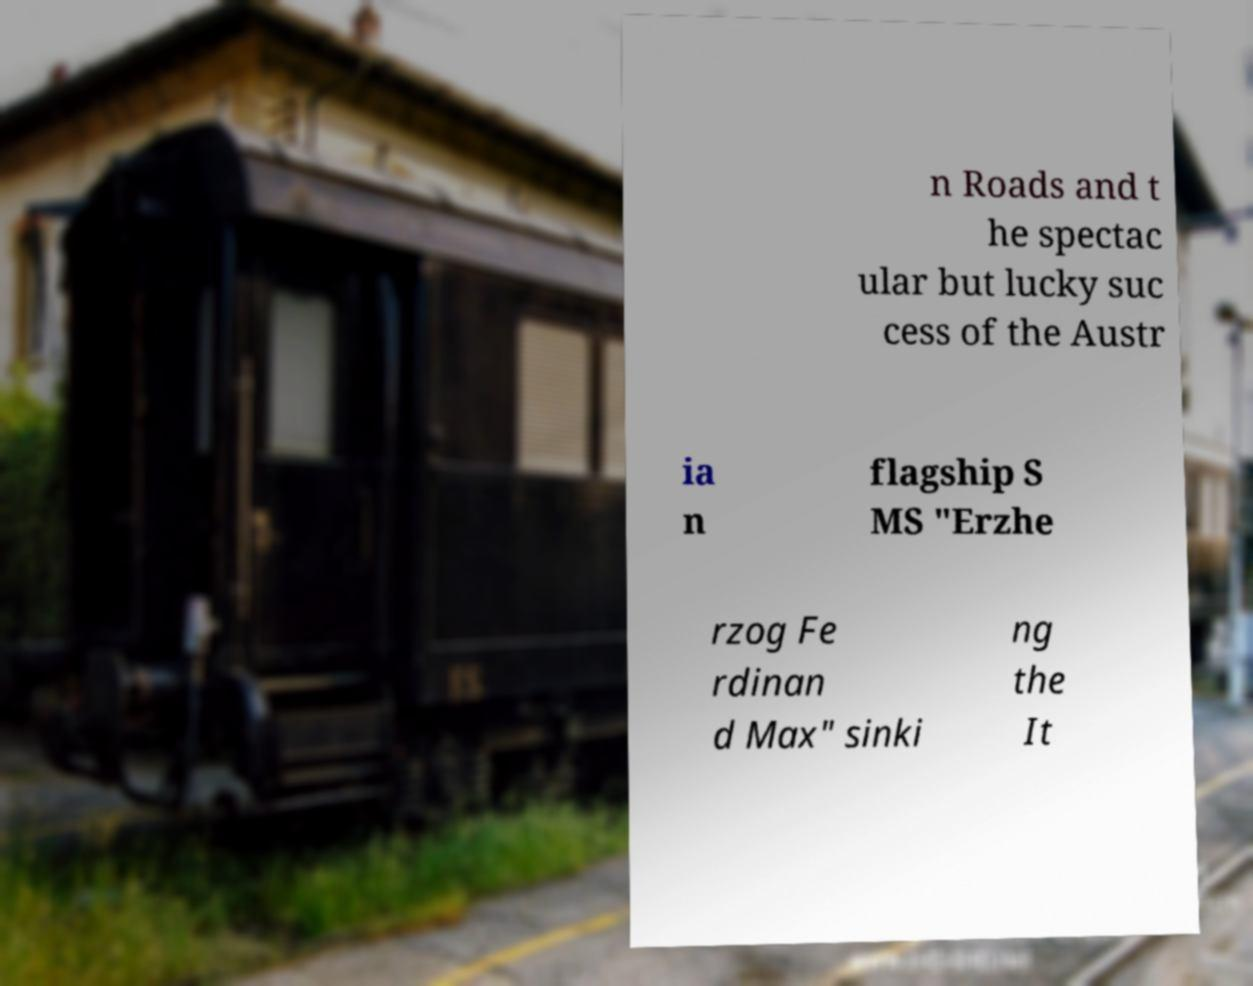Please read and relay the text visible in this image. What does it say? n Roads and t he spectac ular but lucky suc cess of the Austr ia n flagship S MS "Erzhe rzog Fe rdinan d Max" sinki ng the It 